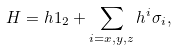Convert formula to latex. <formula><loc_0><loc_0><loc_500><loc_500>H = h 1 _ { 2 } + \sum _ { i = x , y , z } h ^ { i } \sigma _ { i } ,</formula> 